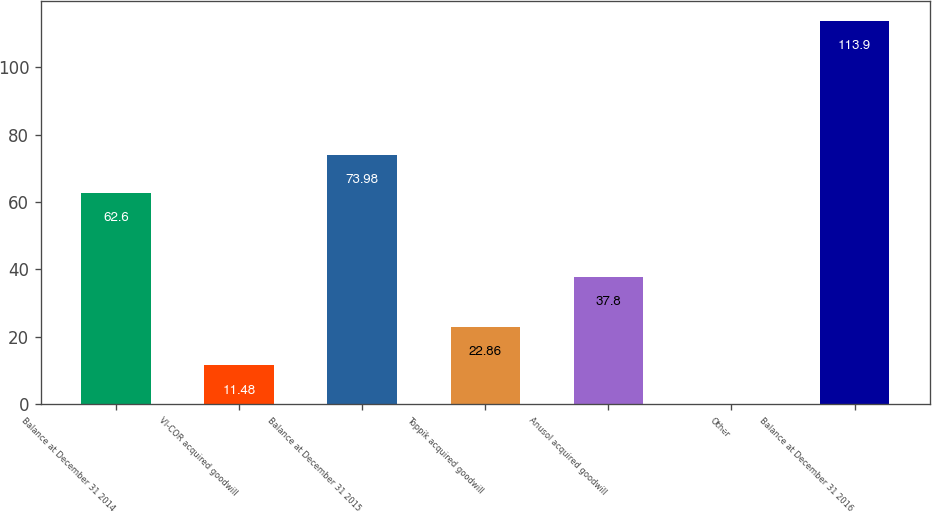Convert chart. <chart><loc_0><loc_0><loc_500><loc_500><bar_chart><fcel>Balance at December 31 2014<fcel>VI-COR acquired goodwill<fcel>Balance at December 31 2015<fcel>Toppik acquired goodwill<fcel>Anusol acquired goodwill<fcel>Other<fcel>Balance at December 31 2016<nl><fcel>62.6<fcel>11.48<fcel>73.98<fcel>22.86<fcel>37.8<fcel>0.1<fcel>113.9<nl></chart> 